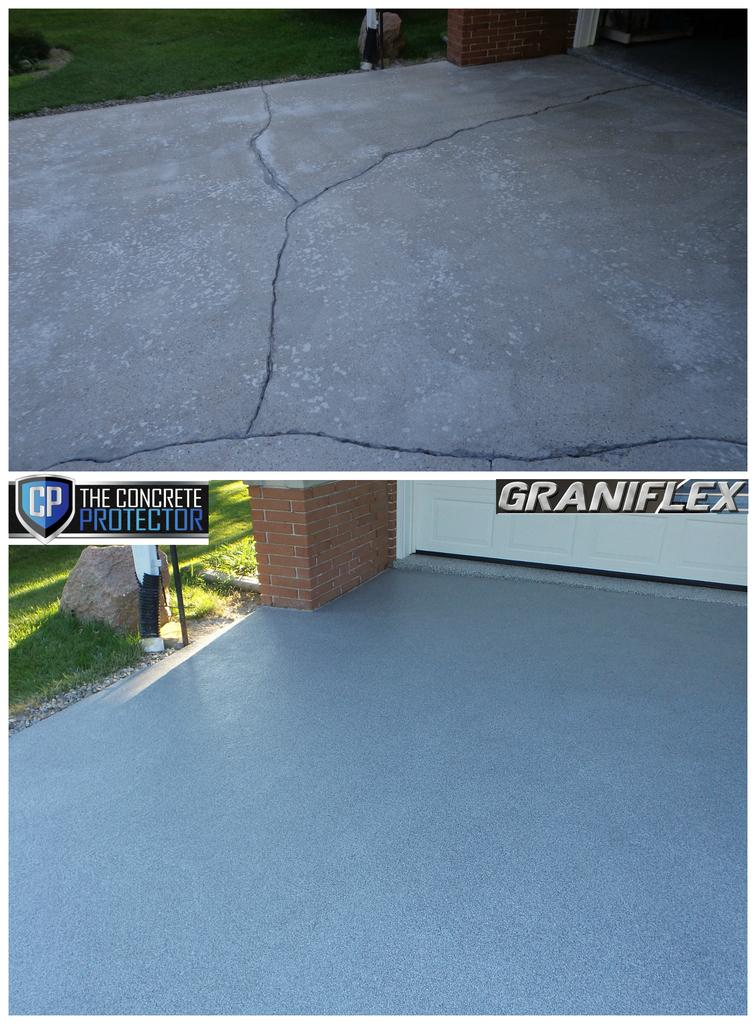What type of image is being described? The image is a collage. What can be seen at the bottom of the image? There is a floor visible in the image. What is the ground covered with in the image? Some part of the ground is covered with grass in the image. What language is being spoken by the person sitting on the chair in the image? There is no person or chair present in the image, so it is not possible to determine what language might be spoken. 